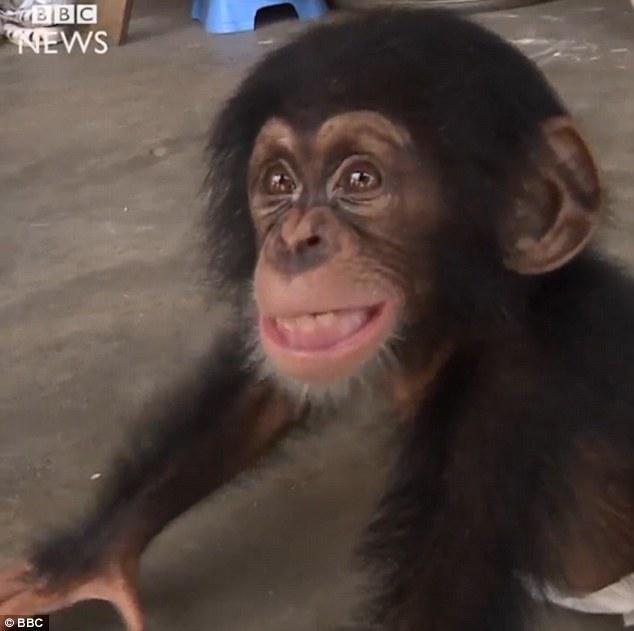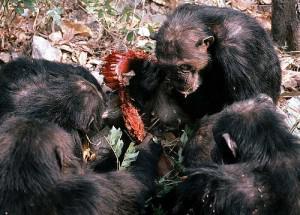The first image is the image on the left, the second image is the image on the right. For the images shown, is this caption "In one of the images, there is just one baby chimpanzee" true? Answer yes or no. Yes. The first image is the image on the left, the second image is the image on the right. Examine the images to the left and right. Is the description "The right image shows an adult chimp sitting upright, with a baby held in front." accurate? Answer yes or no. No. 